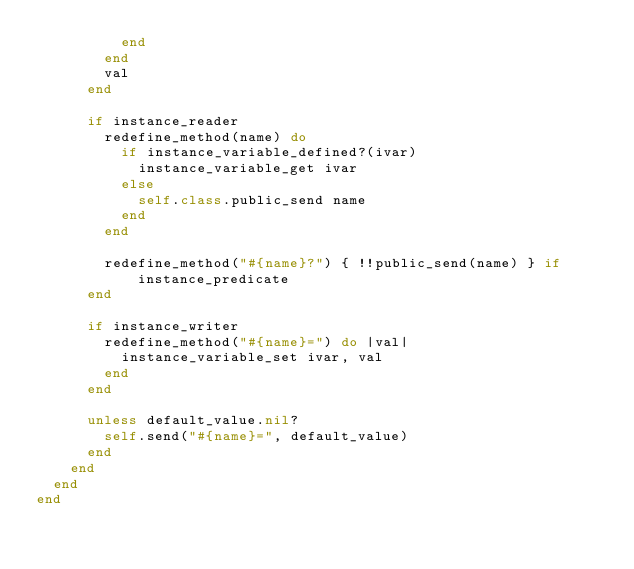Convert code to text. <code><loc_0><loc_0><loc_500><loc_500><_Ruby_>          end
        end
        val
      end

      if instance_reader
        redefine_method(name) do
          if instance_variable_defined?(ivar)
            instance_variable_get ivar
          else
            self.class.public_send name
          end
        end

        redefine_method("#{name}?") { !!public_send(name) } if instance_predicate
      end

      if instance_writer
        redefine_method("#{name}=") do |val|
          instance_variable_set ivar, val
        end
      end

      unless default_value.nil?
        self.send("#{name}=", default_value)
      end
    end
  end
end
</code> 